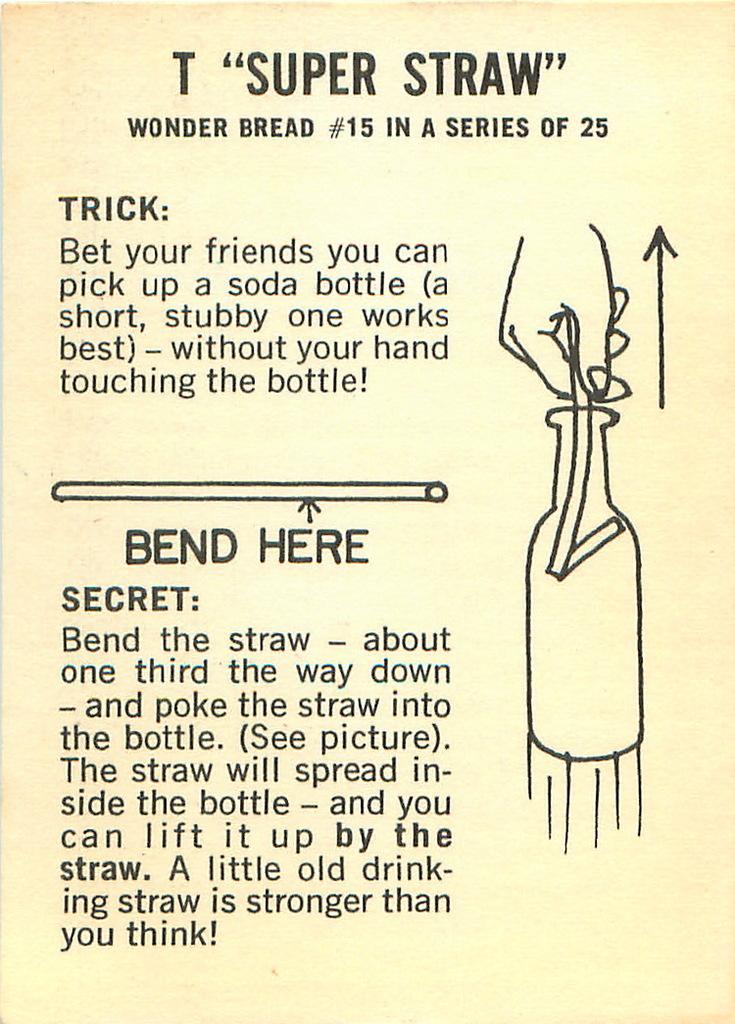Is this about learning to do a  straw trick?
Your answer should be compact. Yes. 